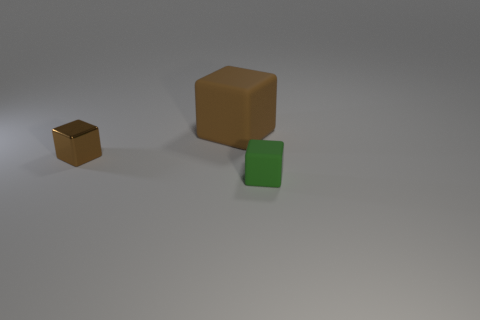What is the color of the rubber block that is the same size as the shiny block?
Your answer should be compact. Green. Do the small thing that is on the left side of the green object and the tiny green matte thing have the same shape?
Provide a succinct answer. Yes. The rubber cube behind the tiny object that is in front of the small object that is behind the tiny matte object is what color?
Provide a short and direct response. Brown. Is there a brown object?
Ensure brevity in your answer.  Yes. What number of other things are the same size as the brown rubber object?
Offer a very short reply. 0. There is a shiny block; is it the same color as the thing behind the shiny object?
Your answer should be compact. Yes. How many things are either green matte cubes or small objects?
Offer a very short reply. 2. Is there any other thing that has the same color as the small matte block?
Your answer should be very brief. No. Is the material of the big block the same as the small object that is left of the big object?
Give a very brief answer. No. There is a rubber thing that is to the right of the matte block behind the small brown shiny object; what is its shape?
Provide a succinct answer. Cube. 